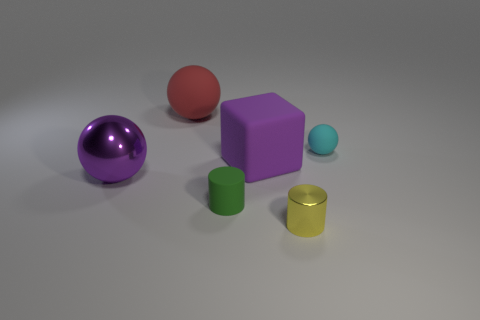Add 4 blue rubber cylinders. How many objects exist? 10 Subtract all blocks. How many objects are left? 5 Subtract all metallic spheres. Subtract all purple rubber blocks. How many objects are left? 4 Add 3 cyan objects. How many cyan objects are left? 4 Add 5 large cyan cubes. How many large cyan cubes exist? 5 Subtract 0 purple cylinders. How many objects are left? 6 